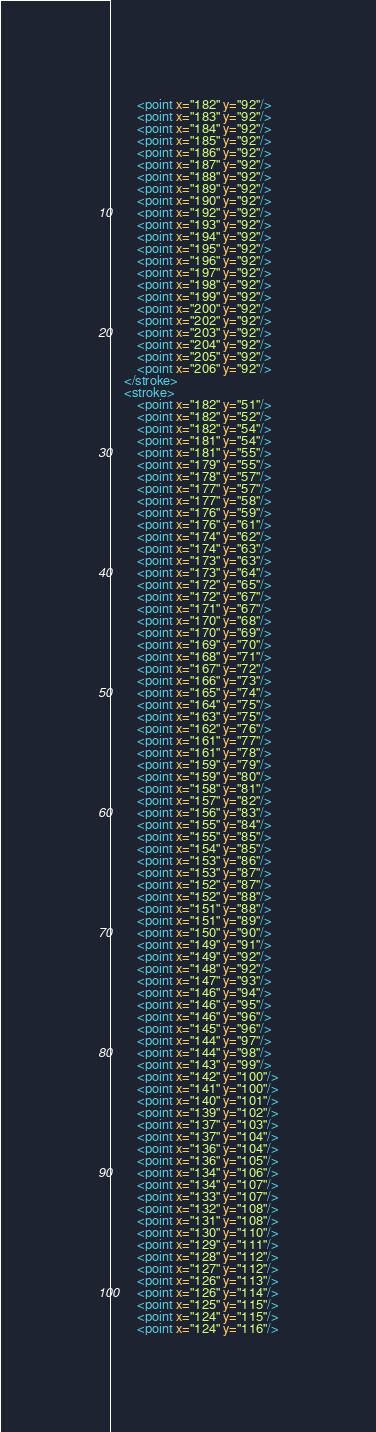Convert code to text. <code><loc_0><loc_0><loc_500><loc_500><_XML_>        <point x="182" y="92"/>
        <point x="183" y="92"/>
        <point x="184" y="92"/>
        <point x="185" y="92"/>
        <point x="186" y="92"/>
        <point x="187" y="92"/>
        <point x="188" y="92"/>
        <point x="189" y="92"/>
        <point x="190" y="92"/>
        <point x="192" y="92"/>
        <point x="193" y="92"/>
        <point x="194" y="92"/>
        <point x="195" y="92"/>
        <point x="196" y="92"/>
        <point x="197" y="92"/>
        <point x="198" y="92"/>
        <point x="199" y="92"/>
        <point x="200" y="92"/>
        <point x="202" y="92"/>
        <point x="203" y="92"/>
        <point x="204" y="92"/>
        <point x="205" y="92"/>
        <point x="206" y="92"/>
    </stroke>
    <stroke>
        <point x="182" y="51"/>
        <point x="182" y="52"/>
        <point x="182" y="54"/>
        <point x="181" y="54"/>
        <point x="181" y="55"/>
        <point x="179" y="55"/>
        <point x="178" y="57"/>
        <point x="177" y="57"/>
        <point x="177" y="58"/>
        <point x="176" y="59"/>
        <point x="176" y="61"/>
        <point x="174" y="62"/>
        <point x="174" y="63"/>
        <point x="173" y="63"/>
        <point x="173" y="64"/>
        <point x="172" y="65"/>
        <point x="172" y="67"/>
        <point x="171" y="67"/>
        <point x="170" y="68"/>
        <point x="170" y="69"/>
        <point x="169" y="70"/>
        <point x="168" y="71"/>
        <point x="167" y="72"/>
        <point x="166" y="73"/>
        <point x="165" y="74"/>
        <point x="164" y="75"/>
        <point x="163" y="75"/>
        <point x="162" y="76"/>
        <point x="161" y="77"/>
        <point x="161" y="78"/>
        <point x="159" y="79"/>
        <point x="159" y="80"/>
        <point x="158" y="81"/>
        <point x="157" y="82"/>
        <point x="156" y="83"/>
        <point x="155" y="84"/>
        <point x="155" y="85"/>
        <point x="154" y="85"/>
        <point x="153" y="86"/>
        <point x="153" y="87"/>
        <point x="152" y="87"/>
        <point x="152" y="88"/>
        <point x="151" y="88"/>
        <point x="151" y="89"/>
        <point x="150" y="90"/>
        <point x="149" y="91"/>
        <point x="149" y="92"/>
        <point x="148" y="92"/>
        <point x="147" y="93"/>
        <point x="146" y="94"/>
        <point x="146" y="95"/>
        <point x="146" y="96"/>
        <point x="145" y="96"/>
        <point x="144" y="97"/>
        <point x="144" y="98"/>
        <point x="143" y="99"/>
        <point x="142" y="100"/>
        <point x="141" y="100"/>
        <point x="140" y="101"/>
        <point x="139" y="102"/>
        <point x="137" y="103"/>
        <point x="137" y="104"/>
        <point x="136" y="104"/>
        <point x="136" y="105"/>
        <point x="134" y="106"/>
        <point x="134" y="107"/>
        <point x="133" y="107"/>
        <point x="132" y="108"/>
        <point x="131" y="108"/>
        <point x="130" y="110"/>
        <point x="129" y="111"/>
        <point x="128" y="112"/>
        <point x="127" y="112"/>
        <point x="126" y="113"/>
        <point x="126" y="114"/>
        <point x="125" y="115"/>
        <point x="124" y="115"/>
        <point x="124" y="116"/></code> 